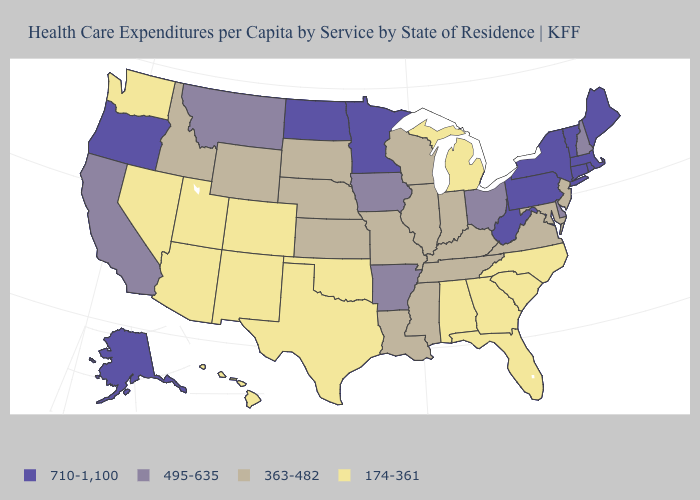Name the states that have a value in the range 363-482?
Be succinct. Idaho, Illinois, Indiana, Kansas, Kentucky, Louisiana, Maryland, Mississippi, Missouri, Nebraska, New Jersey, South Dakota, Tennessee, Virginia, Wisconsin, Wyoming. Does Maryland have the same value as Missouri?
Give a very brief answer. Yes. What is the value of Massachusetts?
Quick response, please. 710-1,100. What is the value of Indiana?
Give a very brief answer. 363-482. What is the value of Wyoming?
Short answer required. 363-482. Among the states that border Utah , which have the highest value?
Concise answer only. Idaho, Wyoming. How many symbols are there in the legend?
Answer briefly. 4. Name the states that have a value in the range 495-635?
Keep it brief. Arkansas, California, Delaware, Iowa, Montana, New Hampshire, Ohio. Is the legend a continuous bar?
Write a very short answer. No. What is the value of Maine?
Give a very brief answer. 710-1,100. What is the value of New Hampshire?
Be succinct. 495-635. Does the map have missing data?
Keep it brief. No. What is the lowest value in the USA?
Quick response, please. 174-361. Among the states that border Connecticut , which have the lowest value?
Concise answer only. Massachusetts, New York, Rhode Island. Among the states that border Maryland , does Pennsylvania have the highest value?
Be succinct. Yes. 